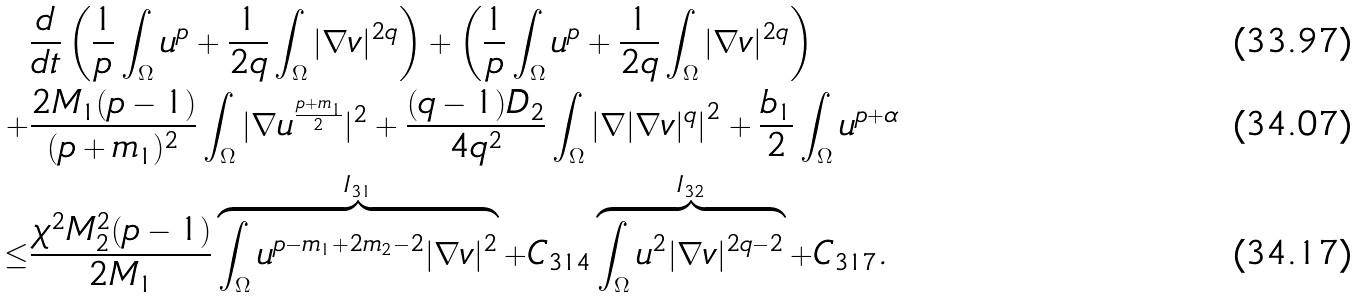<formula> <loc_0><loc_0><loc_500><loc_500>& \frac { d } { d t } \left ( \frac { 1 } { p } \int _ { \Omega } u ^ { p } + \frac { 1 } { 2 q } \int _ { \Omega } | \nabla v | ^ { 2 q } \right ) + \left ( \frac { 1 } { p } \int _ { \Omega } u ^ { p } + \frac { 1 } { 2 q } \int _ { \Omega } | \nabla v | ^ { 2 q } \right ) \\ + & \frac { 2 M _ { 1 } ( p - 1 ) } { ( p + m _ { 1 } ) ^ { 2 } } \int _ { \Omega } | \nabla u ^ { \frac { p + m _ { 1 } } { 2 } } | ^ { 2 } + \frac { ( q - 1 ) D _ { 2 } } { 4 q ^ { 2 } } \int _ { \Omega } \left | \nabla | \nabla v | ^ { q } \right | ^ { 2 } + \frac { b _ { 1 } } { 2 } \int _ { \Omega } u ^ { p + \alpha } \\ \leq & \frac { \chi ^ { 2 } M _ { 2 } ^ { 2 } ( p - 1 ) } { 2 M _ { 1 } } \overbrace { \int _ { \Omega } u ^ { p - m _ { 1 } + 2 m _ { 2 } - 2 } | \nabla v | ^ { 2 } } ^ { I _ { 3 1 } } + C _ { 3 1 4 } \overbrace { \int _ { \Omega } u ^ { 2 } | \nabla v | ^ { 2 q - 2 } } ^ { I _ { 3 2 } } + C _ { 3 1 7 } .</formula> 